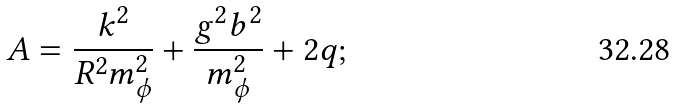Convert formula to latex. <formula><loc_0><loc_0><loc_500><loc_500>A = \frac { k ^ { 2 } } { R ^ { 2 } m _ { \phi } ^ { 2 } } + \frac { g ^ { 2 } b ^ { 2 } } { m _ { \phi } ^ { 2 } } + 2 q ;</formula> 